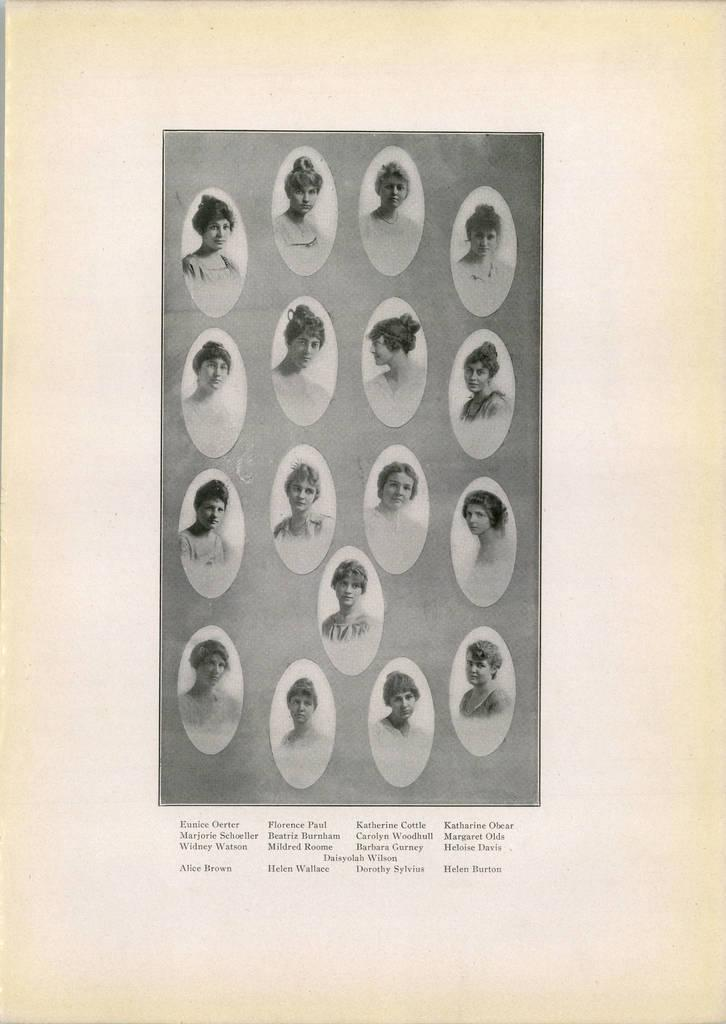What type of content is present in the image? The image contains photos of people. Is there any additional information provided with the photos? Yes, there is text at the bottom of the image. What is the size of the snowflakes in the image? There is no snow or snowflakes present in the image; it contains photos of people and text. 